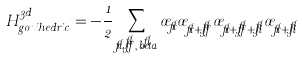Convert formula to latex. <formula><loc_0><loc_0><loc_500><loc_500>H _ { g o n i h e d r i c } ^ { 3 d } = - \frac { 1 } { 2 } \sum _ { \vec { r } , \vec { \alpha } , \vec { b e t a } } \sigma _ { \vec { r } } \sigma _ { \vec { r } + \vec { \alpha } } \sigma _ { \vec { r } + \vec { \alpha } + \vec { \beta } } \sigma _ { \vec { r } + \vec { \beta } }</formula> 